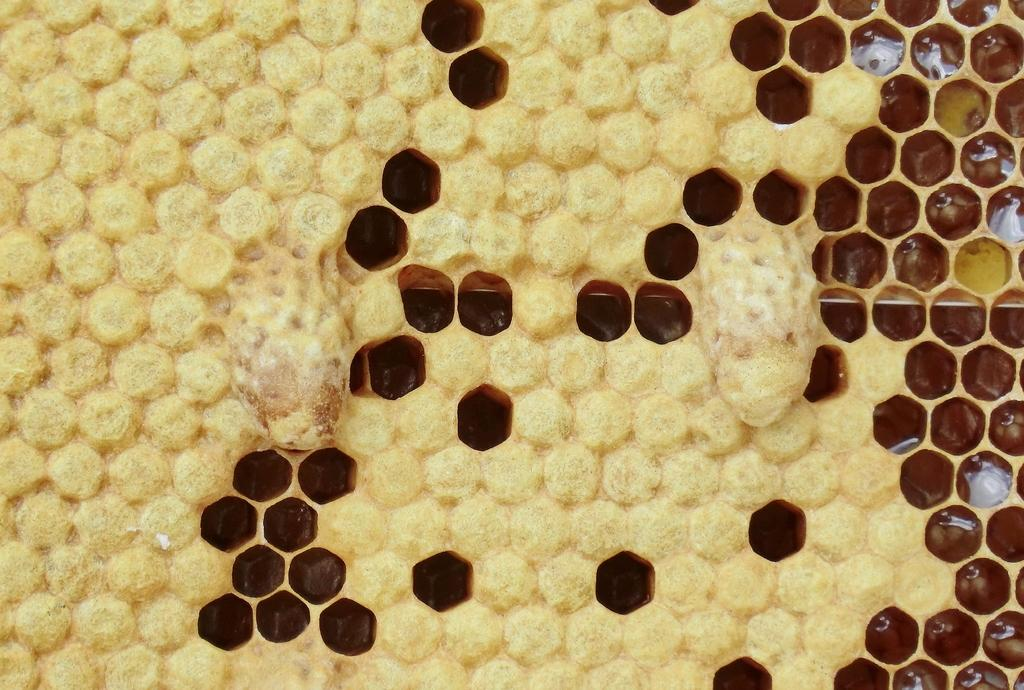What is the main subject of the image? The main subject of the image is a yellow honeycomb. Can you describe the honeycomb in more detail? Yes, the honeycomb has holes. What type of card is being used to clean the soap in the image? There is no card or soap present in the image; it only features a yellow honeycomb with holes. 